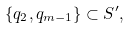<formula> <loc_0><loc_0><loc_500><loc_500>\{ q _ { 2 } , q _ { m - 1 } \} \subset S ^ { \prime } ,</formula> 